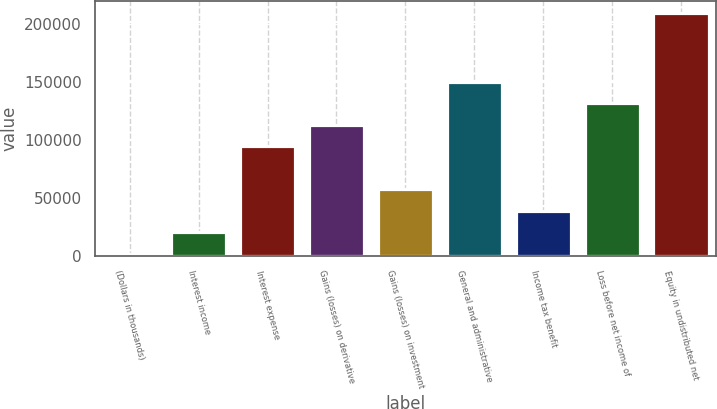Convert chart. <chart><loc_0><loc_0><loc_500><loc_500><bar_chart><fcel>(Dollars in thousands)<fcel>Interest income<fcel>Interest expense<fcel>Gains (losses) on derivative<fcel>Gains (losses) on investment<fcel>General and administrative<fcel>Income tax benefit<fcel>Loss before net income of<fcel>Equity in undistributed net<nl><fcel>2011<fcel>20515.4<fcel>94533<fcel>113037<fcel>57524.2<fcel>150046<fcel>39019.8<fcel>131542<fcel>208911<nl></chart> 